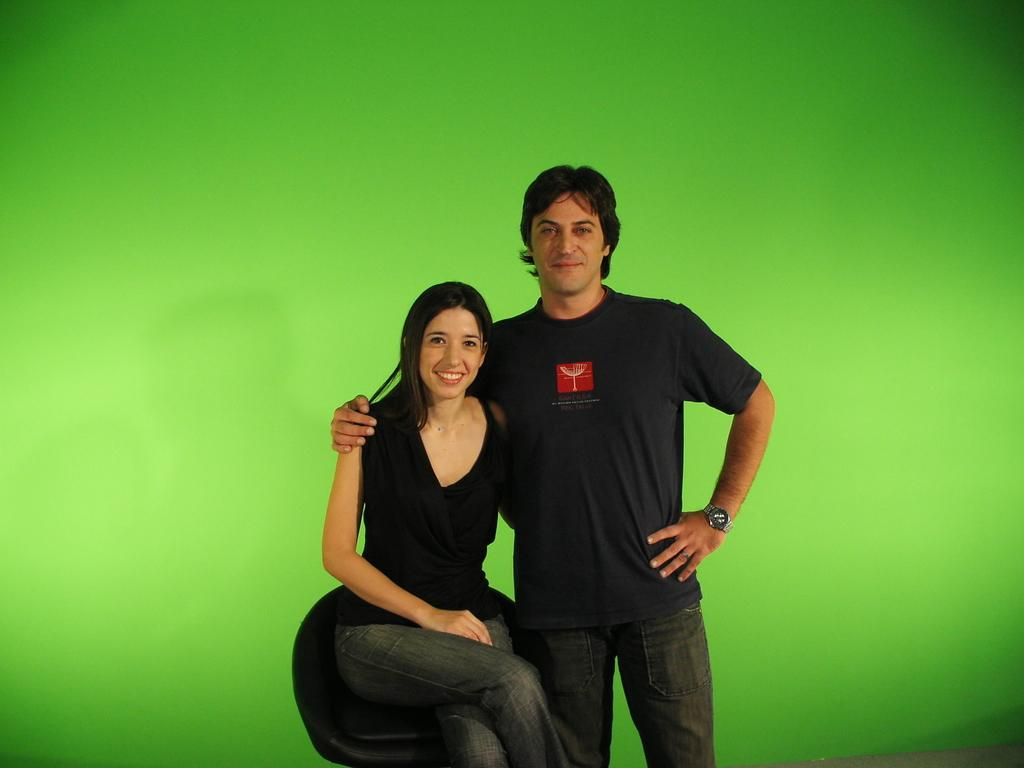What is the girl in the image doing? The girl is sitting on a chair in the image. How does the girl appear in the image? The girl has a smile on her face. Is there anyone else in the image besides the girl? Yes, there is a person standing beside the girl. What can be seen in the background of the image? There is a wall in the background of the image. What is the color of the wall in the image? The wall is green in color. What type of surprise does the girl receive from the person standing beside her in the image? There is no indication in the image that the girl is receiving a surprise from the person standing beside her. 